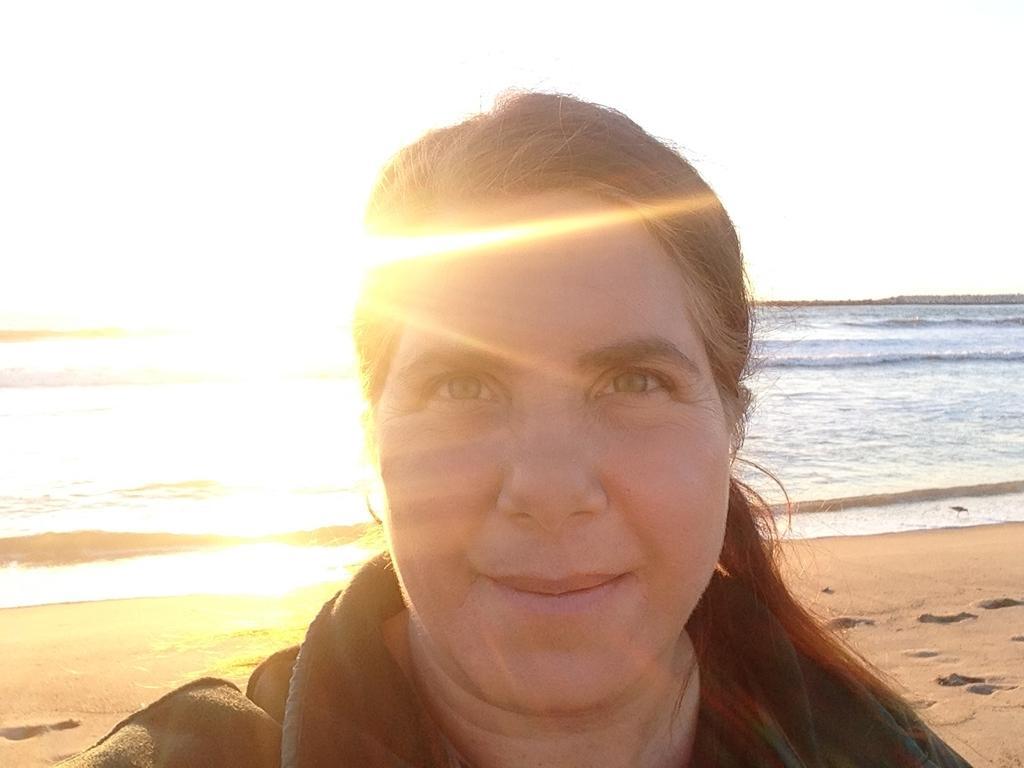How would you summarize this image in a sentence or two? In the foreground of the image we can see a woman. In the background, we can see sand, water, sunlight and sky. 